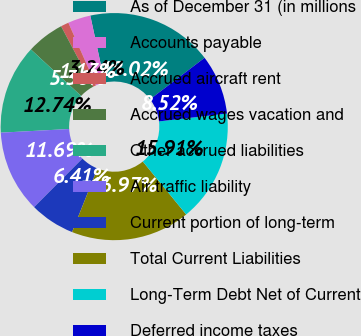Convert chart to OTSL. <chart><loc_0><loc_0><loc_500><loc_500><pie_chart><fcel>As of December 31 (in millions<fcel>Accounts payable<fcel>Accrued aircraft rent<fcel>Accrued wages vacation and<fcel>Other accrued liabilities<fcel>Air traffic liability<fcel>Current portion of long-term<fcel>Total Current Liabilities<fcel>Long-Term Debt Net of Current<fcel>Deferred income taxes<nl><fcel>18.02%<fcel>3.24%<fcel>1.13%<fcel>5.36%<fcel>12.74%<fcel>11.69%<fcel>6.41%<fcel>16.97%<fcel>15.91%<fcel>8.52%<nl></chart> 